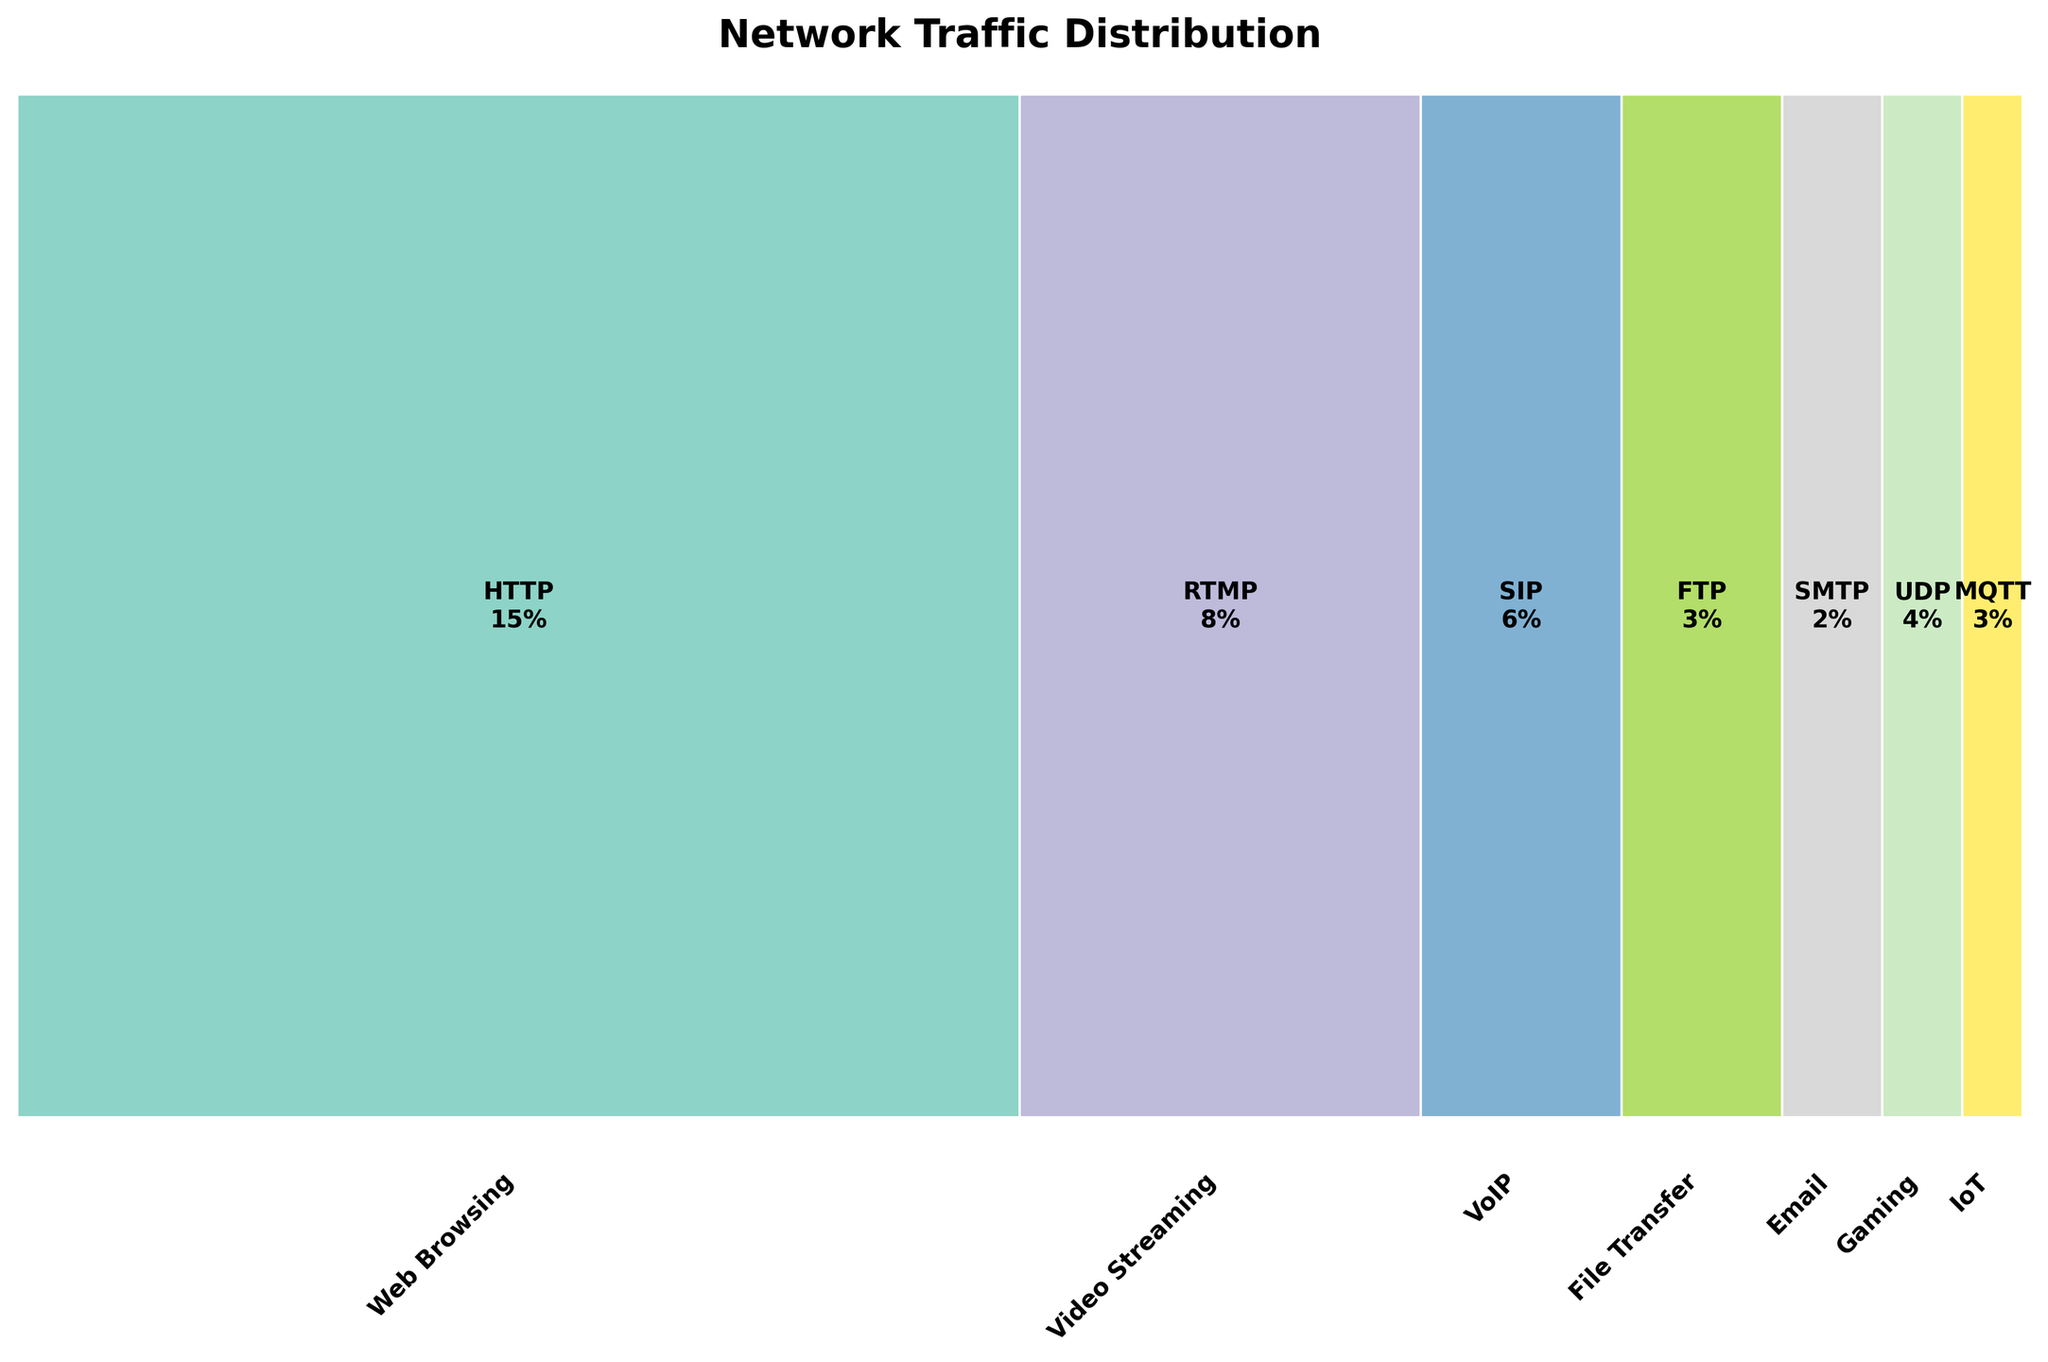What is the title of the figure? The title of any figure is typically located at the top of the chart. In this case, it reads "Network Traffic Distribution".
Answer: Network Traffic Distribution Which application has the highest traffic percentage? By observing the widths of the bars in the mosaic plot, the widest bar indicates the application with the highest traffic percentage.
Answer: Web Browsing How many protocols are used for Email? By examining the sections within the Email application, we see two protocols annotated in the mosaic plot.
Answer: 2 What is the difference in traffic between HTTP and HTTPS? Referring to the annotations in the plot, HTTP has 15% traffic and HTTPS has 35% traffic. The difference is 35% - 15%.
Answer: 20% Compare the traffic percentage of VoIP and Gaming. Which one is greater? By looking at the widths of the sections and their annotations for VoIP and Gaming, VoIP comprises (SIP 6% + RTP 4%) = 10% and Gaming has 4%.
Answer: VoIP Which protocol within the File Transfer application has more traffic percentage? Observing the segments within the File Transfer application, the protocol with the higher annotation will have a greater traffic percentage.
Answer: SFTP What is the combined traffic percentage of IoT and Gaming? Summing up the individual percentages of IoT (3%) and Gaming (4%), we find their total.
Answer: 7% Compare the traffic of RTP protocol to IMAP protocol. Which one is higher? RTP under VoIP shows 4%, whereas IMAP under Email shows 3%. Therefore, RTP has a higher traffic percentage.
Answer: RTP What is the smallest traffic percentage shown in the figure? By scanning through all annotations, the smallest value observed is associated with the SMTP protocol.
Answer: 2% 